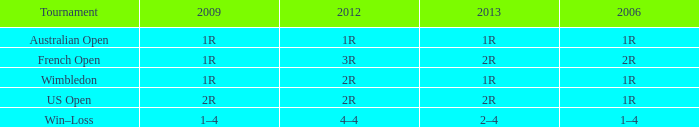Help me parse the entirety of this table. {'header': ['Tournament', '2009', '2012', '2013', '2006'], 'rows': [['Australian Open', '1R', '1R', '1R', '1R'], ['French Open', '1R', '3R', '2R', '2R'], ['Wimbledon', '1R', '2R', '1R', '1R'], ['US Open', '2R', '2R', '2R', '1R'], ['Win–Loss', '1–4', '4–4', '2–4', '1–4']]} What shows for 2006, when 2013 is 2–4? 1–4. 